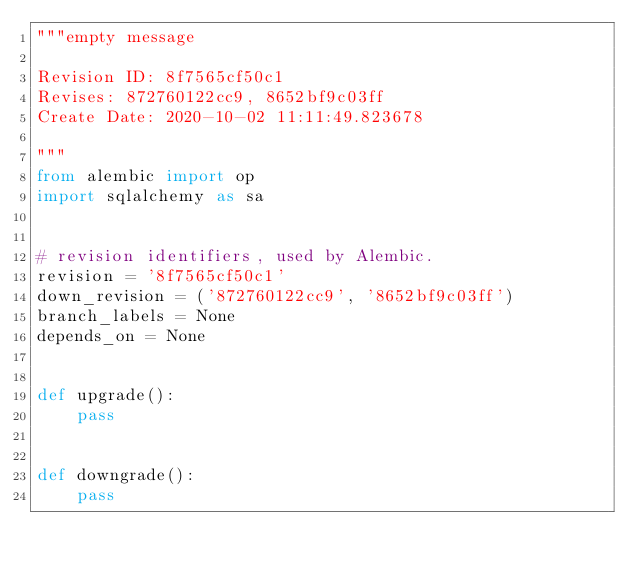Convert code to text. <code><loc_0><loc_0><loc_500><loc_500><_Python_>"""empty message

Revision ID: 8f7565cf50c1
Revises: 872760122cc9, 8652bf9c03ff
Create Date: 2020-10-02 11:11:49.823678

"""
from alembic import op
import sqlalchemy as sa


# revision identifiers, used by Alembic.
revision = '8f7565cf50c1'
down_revision = ('872760122cc9', '8652bf9c03ff')
branch_labels = None
depends_on = None


def upgrade():
    pass


def downgrade():
    pass
</code> 